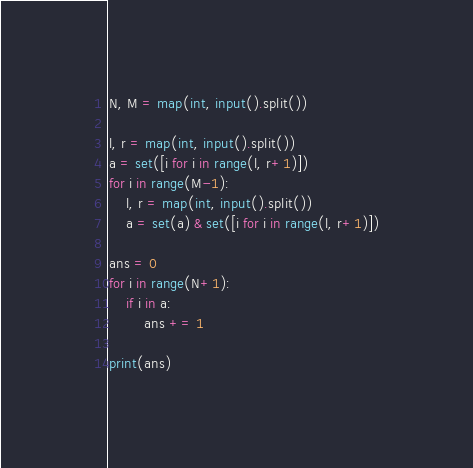Convert code to text. <code><loc_0><loc_0><loc_500><loc_500><_Python_>N, M = map(int, input().split())

l, r = map(int, input().split())
a = set([i for i in range(l, r+1)])
for i in range(M-1):
    l, r = map(int, input().split())
    a = set(a) & set([i for i in range(l, r+1)])

ans = 0
for i in range(N+1):
    if i in a:
        ans += 1

print(ans)</code> 